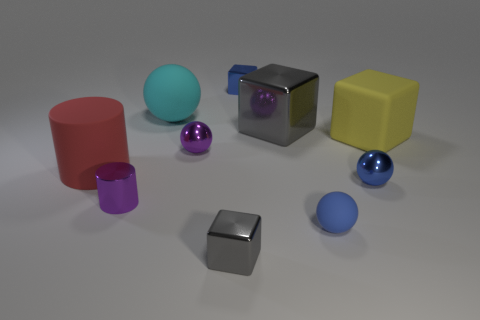Can you tell me what materials the objects seem to be made of? Certainly! The objects in the image seem to be made of various materials. The yellow and the grey cubes look like they could be made of plastic, the blue and red spheres as well as the red cylinder might be rubber due to their matte texture. The purple objects, both the cylinder and the sphere, appear metallic given their reflective surface, as does the smaller grey cube. 